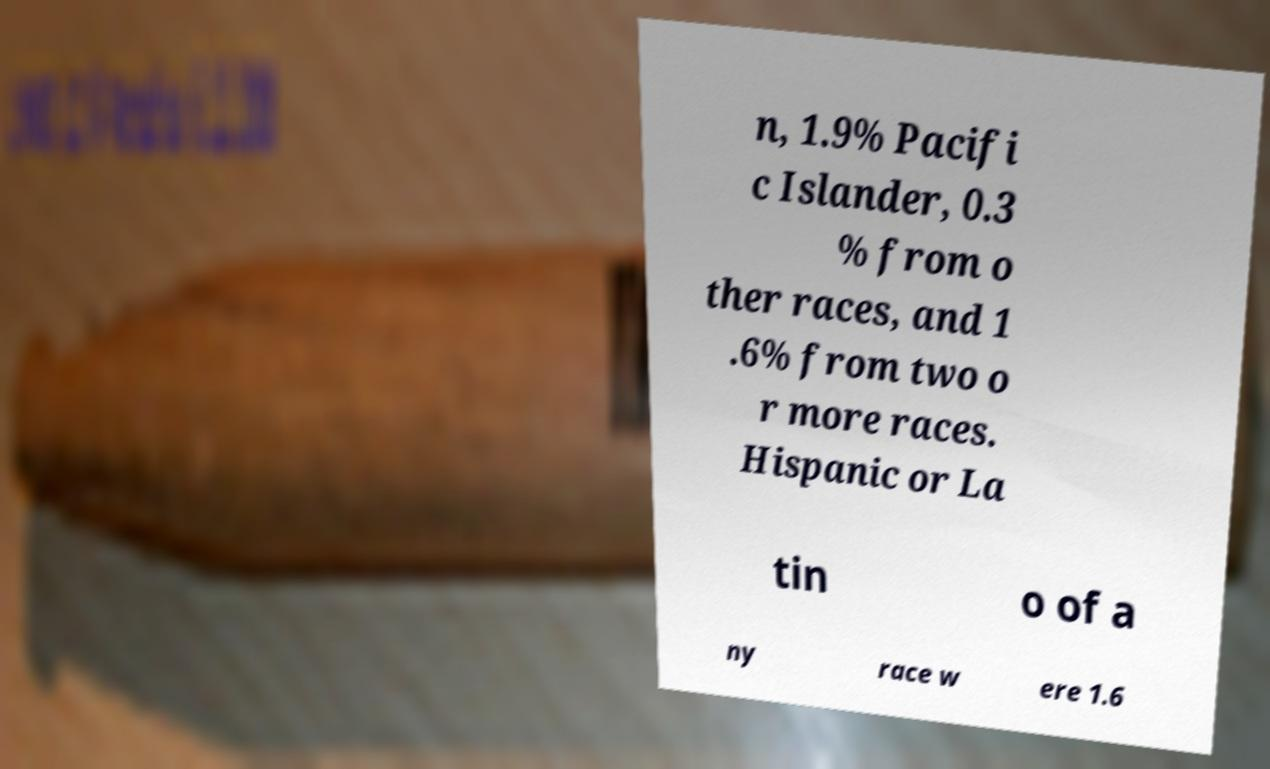Please read and relay the text visible in this image. What does it say? n, 1.9% Pacifi c Islander, 0.3 % from o ther races, and 1 .6% from two o r more races. Hispanic or La tin o of a ny race w ere 1.6 